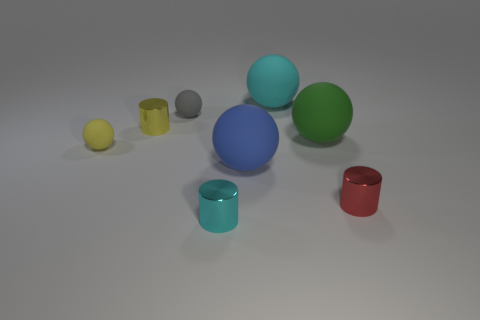There is another tiny object that is the same shape as the tiny yellow rubber object; what is its color?
Provide a short and direct response. Gray. What is the size of the cylinder that is on the right side of the big cyan ball?
Provide a short and direct response. Small. Is the number of blue balls right of the green rubber sphere greater than the number of red shiny things?
Ensure brevity in your answer.  No. The blue object is what shape?
Give a very brief answer. Sphere. There is a cylinder that is right of the cyan shiny cylinder; does it have the same color as the small rubber ball left of the gray rubber ball?
Offer a very short reply. No. Is the shape of the large cyan thing the same as the yellow metal thing?
Your answer should be very brief. No. Is there anything else that has the same shape as the blue object?
Offer a terse response. Yes. Are the small yellow thing that is in front of the big green rubber object and the big cyan thing made of the same material?
Make the answer very short. Yes. What is the shape of the rubber thing that is both in front of the gray rubber thing and on the left side of the cyan metallic cylinder?
Keep it short and to the point. Sphere. There is a small matte ball that is in front of the gray thing; is there a tiny gray object right of it?
Your response must be concise. Yes. 